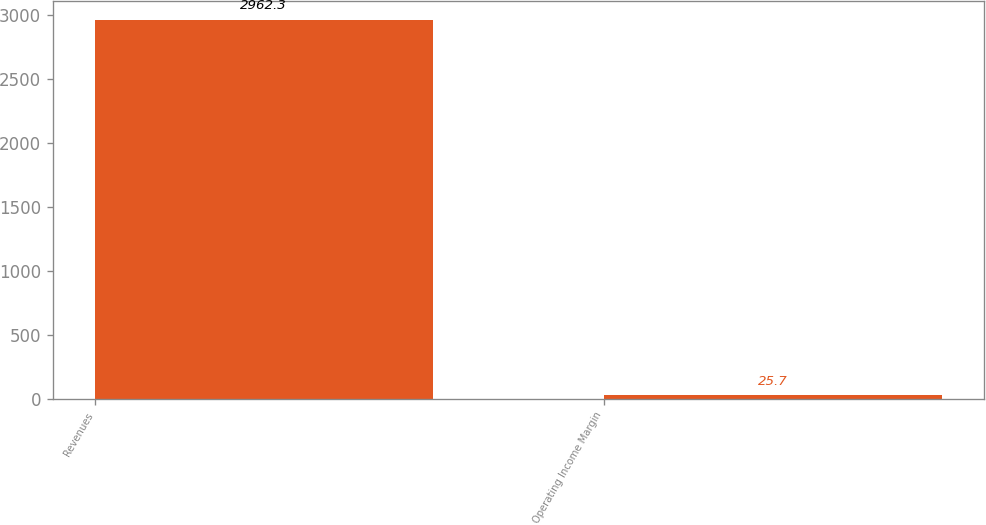Convert chart to OTSL. <chart><loc_0><loc_0><loc_500><loc_500><bar_chart><fcel>Revenues<fcel>Operating Income Margin<nl><fcel>2962.3<fcel>25.7<nl></chart> 